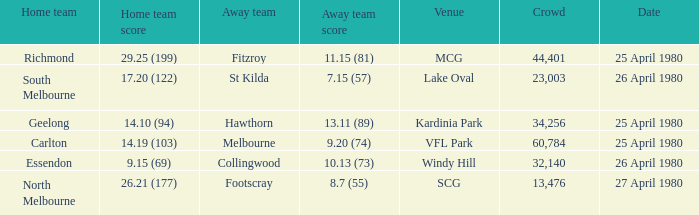What wa the date of the North Melbourne home game? 27 April 1980. 